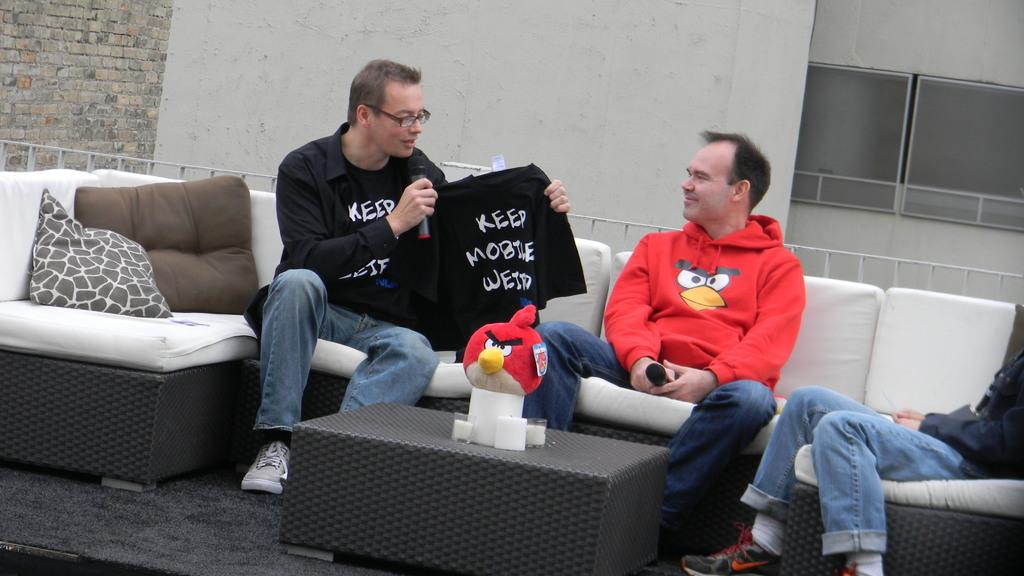How many people are seated on the sofa set in the image? There are three people seated on the sofa set in the image. What can be seen on the sofa set besides the people? There are two pillows on the sofa set. What is the man holding in his hands? The man is holding a t-shirt in his hands. What is the man doing with the microphone? The man is speaking using a microphone. What is the father doing in the image? There is no mention of a father in the image, so it is not possible to answer that question. 